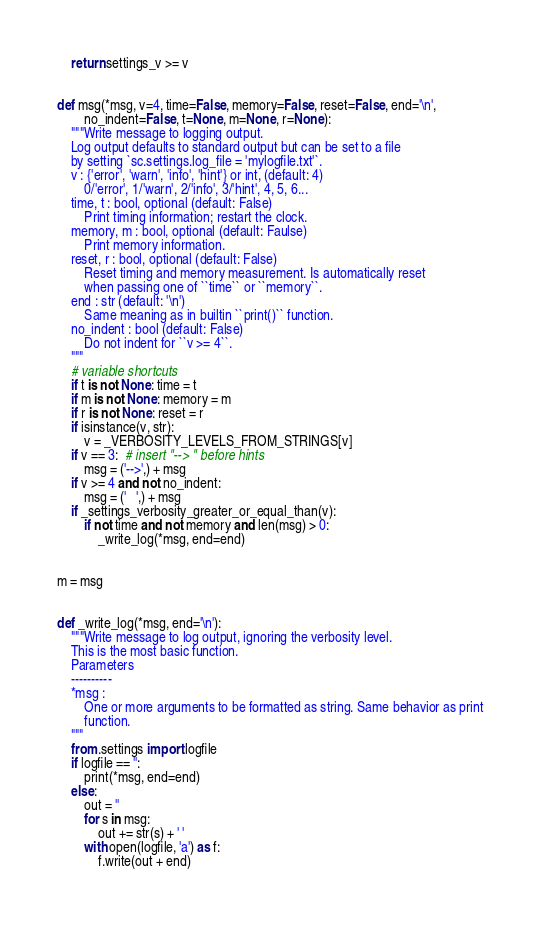Convert code to text. <code><loc_0><loc_0><loc_500><loc_500><_Python_>    return settings_v >= v


def msg(*msg, v=4, time=False, memory=False, reset=False, end='\n',
        no_indent=False, t=None, m=None, r=None):
    """Write message to logging output.
    Log output defaults to standard output but can be set to a file
    by setting `sc.settings.log_file = 'mylogfile.txt'`.
    v : {'error', 'warn', 'info', 'hint'} or int, (default: 4)
        0/'error', 1/'warn', 2/'info', 3/'hint', 4, 5, 6...
    time, t : bool, optional (default: False)
        Print timing information; restart the clock.
    memory, m : bool, optional (default: Faulse)
        Print memory information.
    reset, r : bool, optional (default: False)
        Reset timing and memory measurement. Is automatically reset
        when passing one of ``time`` or ``memory``.
    end : str (default: '\n')
        Same meaning as in builtin ``print()`` function.
    no_indent : bool (default: False)
        Do not indent for ``v >= 4``.
    """
    # variable shortcuts
    if t is not None: time = t
    if m is not None: memory = m
    if r is not None: reset = r
    if isinstance(v, str):
        v = _VERBOSITY_LEVELS_FROM_STRINGS[v]
    if v == 3:  # insert "--> " before hints
        msg = ('-->',) + msg
    if v >= 4 and not no_indent:
        msg = ('   ',) + msg
    if _settings_verbosity_greater_or_equal_than(v):
        if not time and not memory and len(msg) > 0:
            _write_log(*msg, end=end)


m = msg


def _write_log(*msg, end='\n'):
    """Write message to log output, ignoring the verbosity level.
    This is the most basic function.
    Parameters
    ----------
    *msg :
        One or more arguments to be formatted as string. Same behavior as print
        function.
    """
    from .settings import logfile
    if logfile == '':
        print(*msg, end=end)
    else:
        out = ''
        for s in msg:
            out += str(s) + ' '
        with open(logfile, 'a') as f:
            f.write(out + end)

</code> 